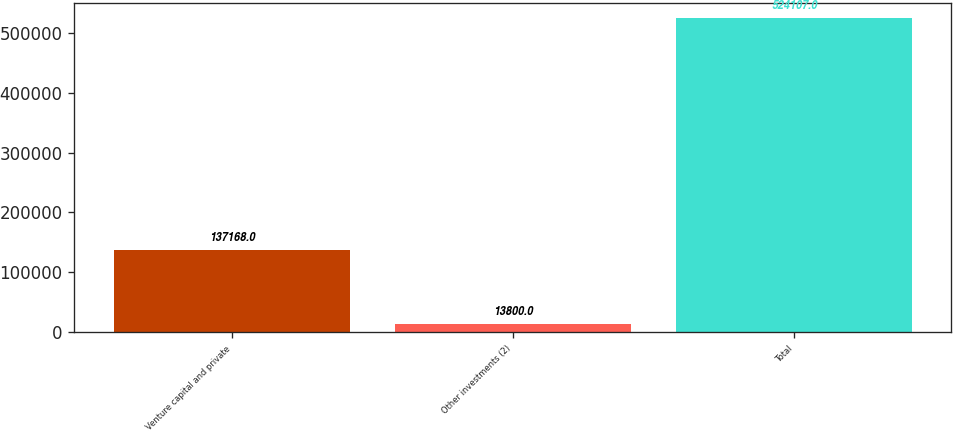<chart> <loc_0><loc_0><loc_500><loc_500><bar_chart><fcel>Venture capital and private<fcel>Other investments (2)<fcel>Total<nl><fcel>137168<fcel>13800<fcel>524107<nl></chart> 